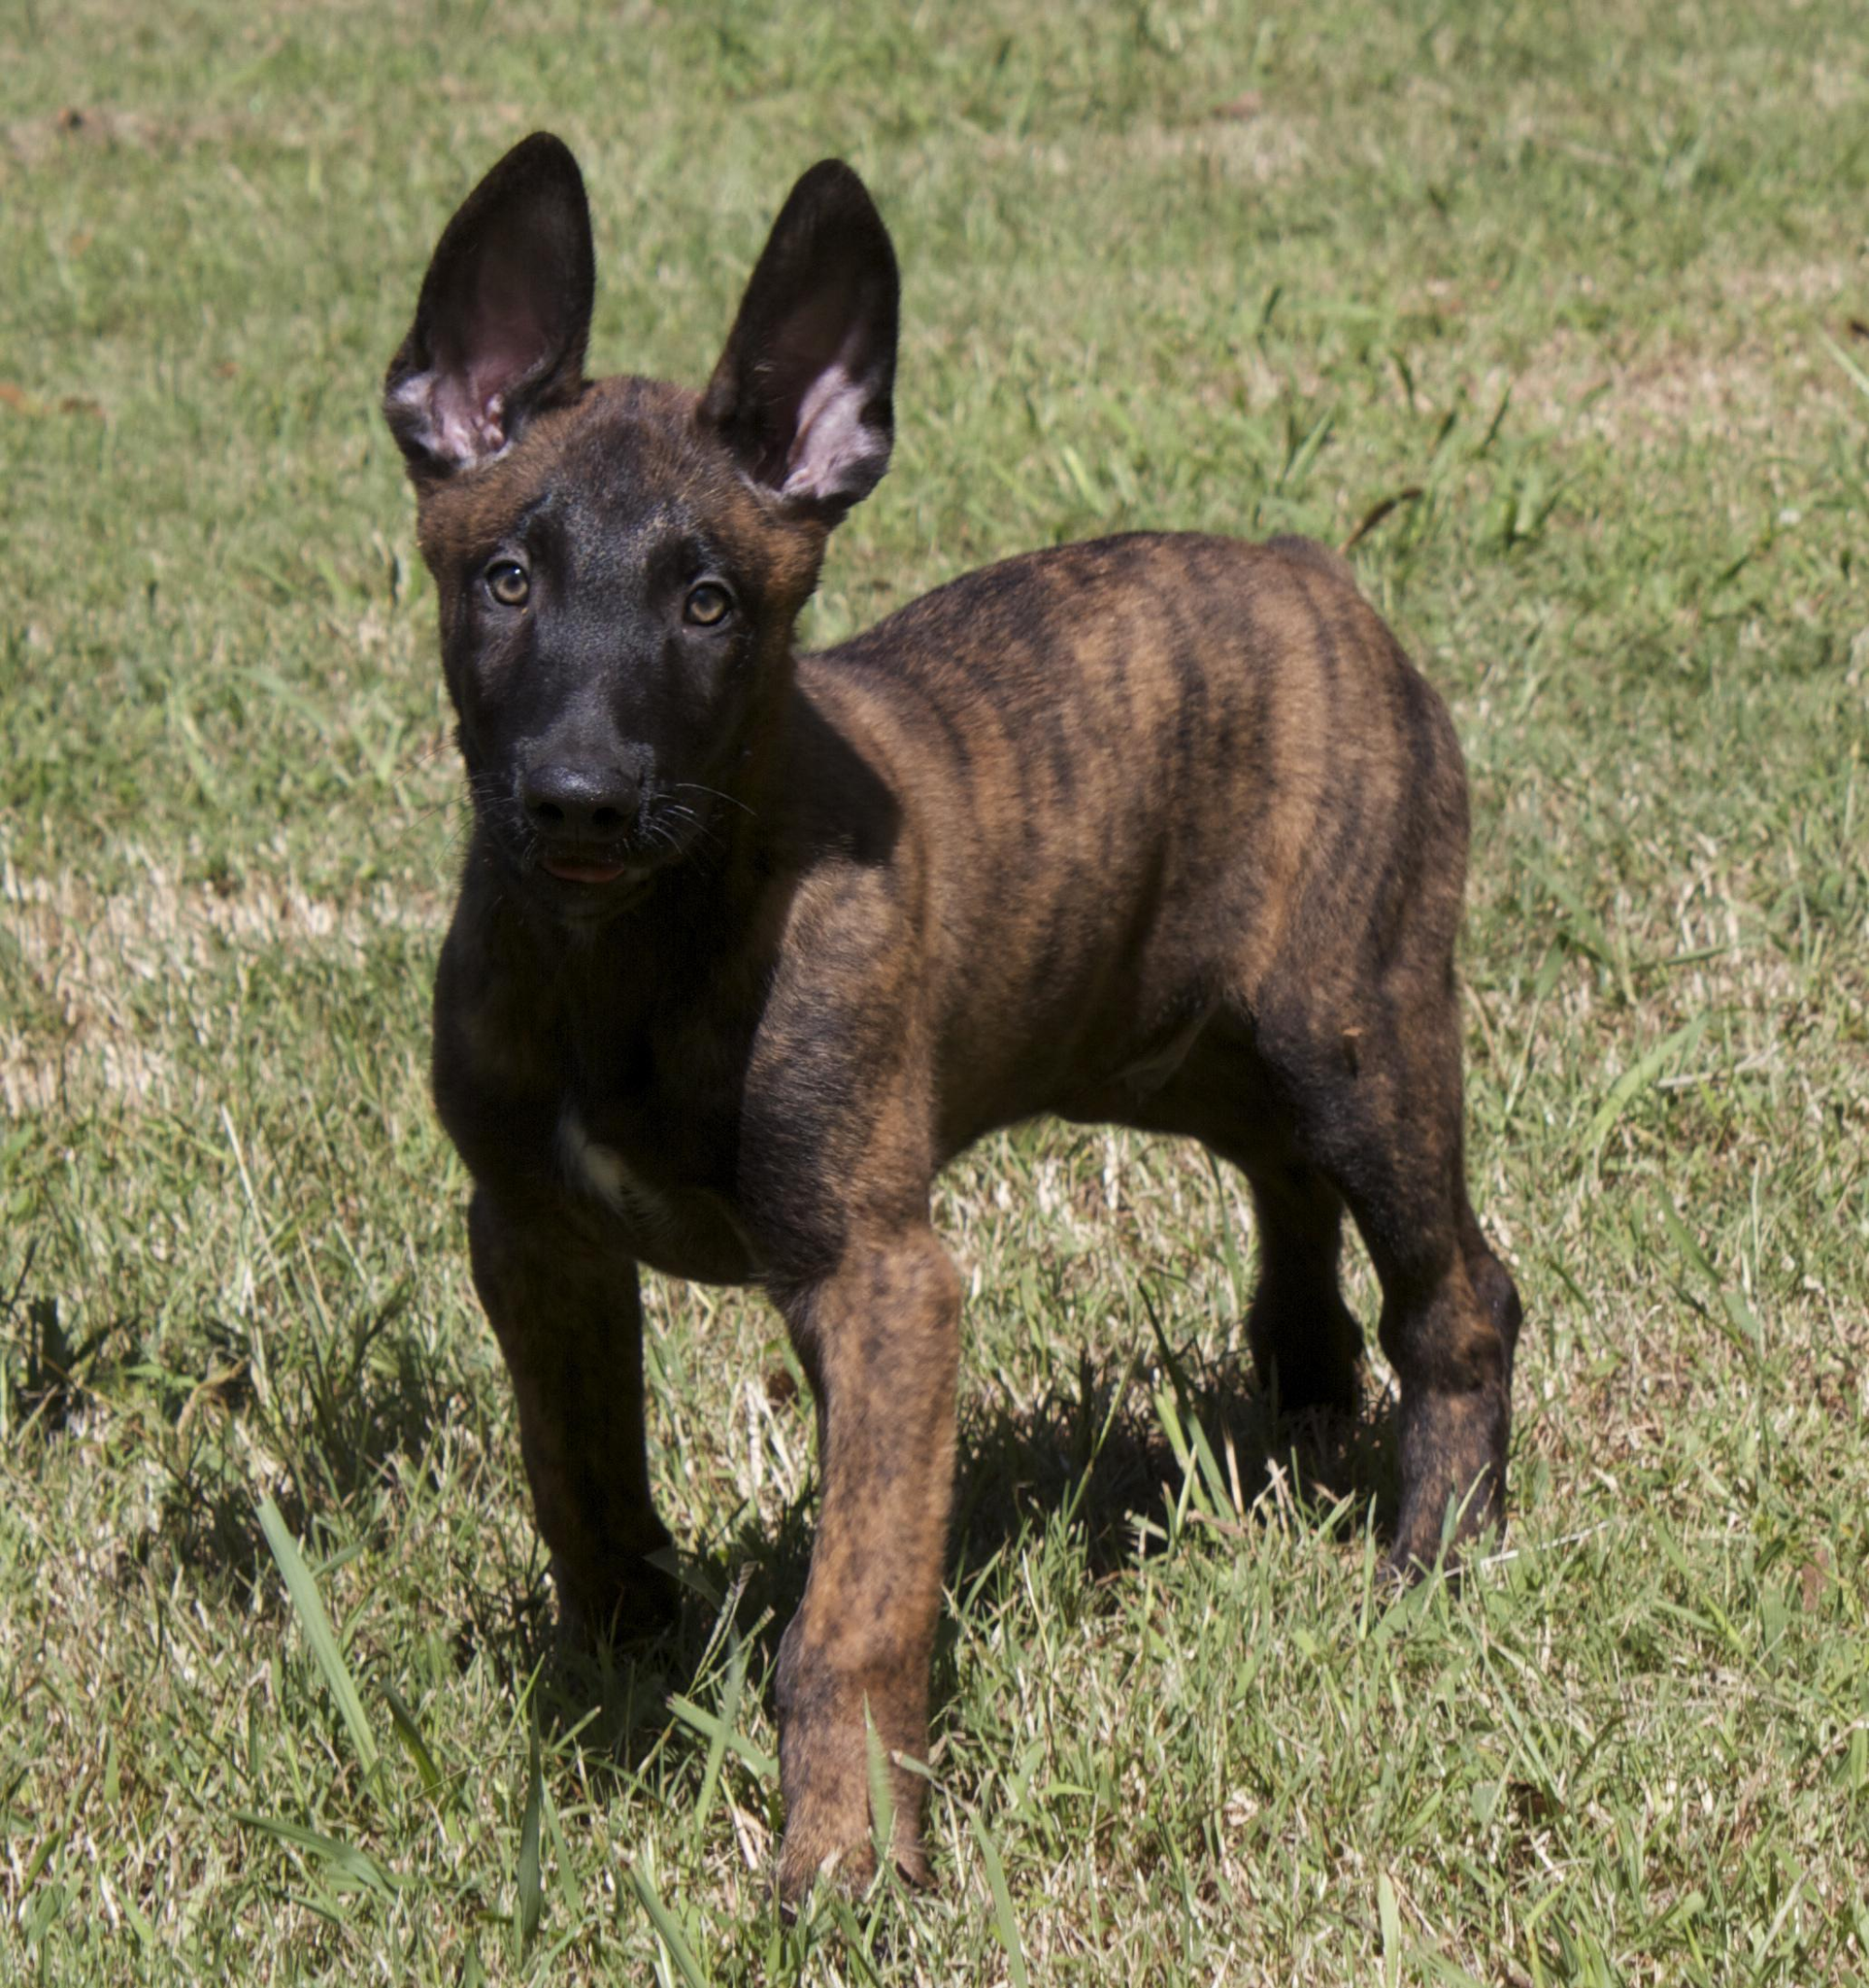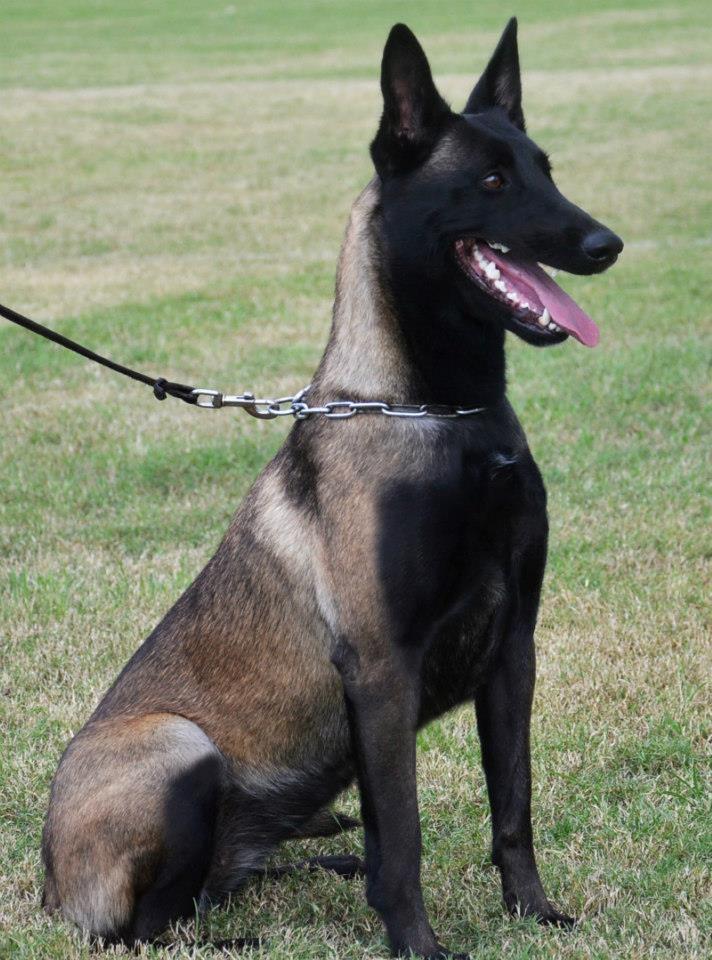The first image is the image on the left, the second image is the image on the right. Given the left and right images, does the statement "An image shows a dog sitting upright in grass, wearing a leash." hold true? Answer yes or no. Yes. 